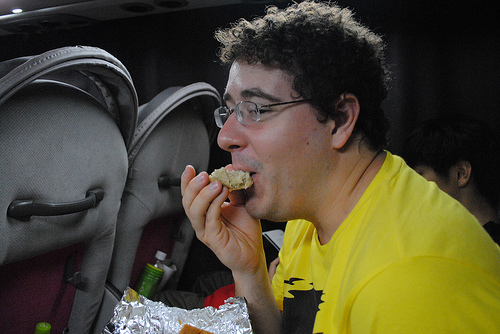<image>
Can you confirm if the food is in the tin foil? Yes. The food is contained within or inside the tin foil, showing a containment relationship. Is the cookie in the man? Yes. The cookie is contained within or inside the man, showing a containment relationship. 